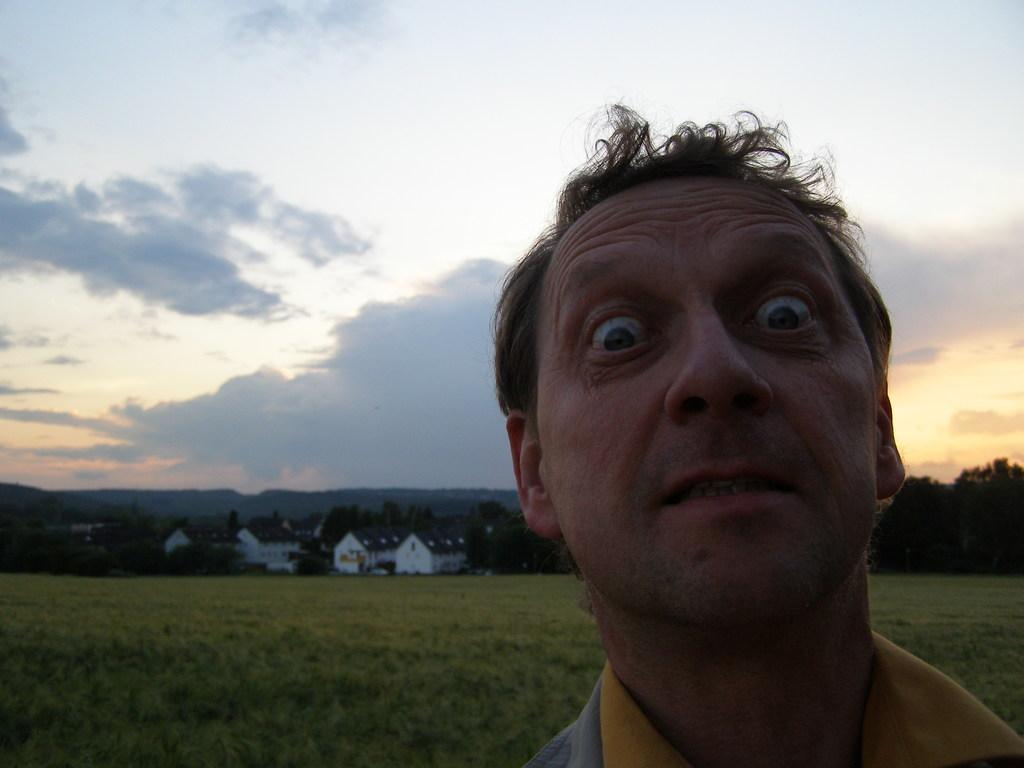Who or what is in the image? There is a person in the image. What is behind the person? There is grass, trees, buildings, and mountains behind the person. What can be seen in the sky in the image? The sky is visible in the image. What type of muscle is being flexed by the person in the image? There is no indication in the image that the person is flexing any muscles, so it cannot be determined from the picture. 